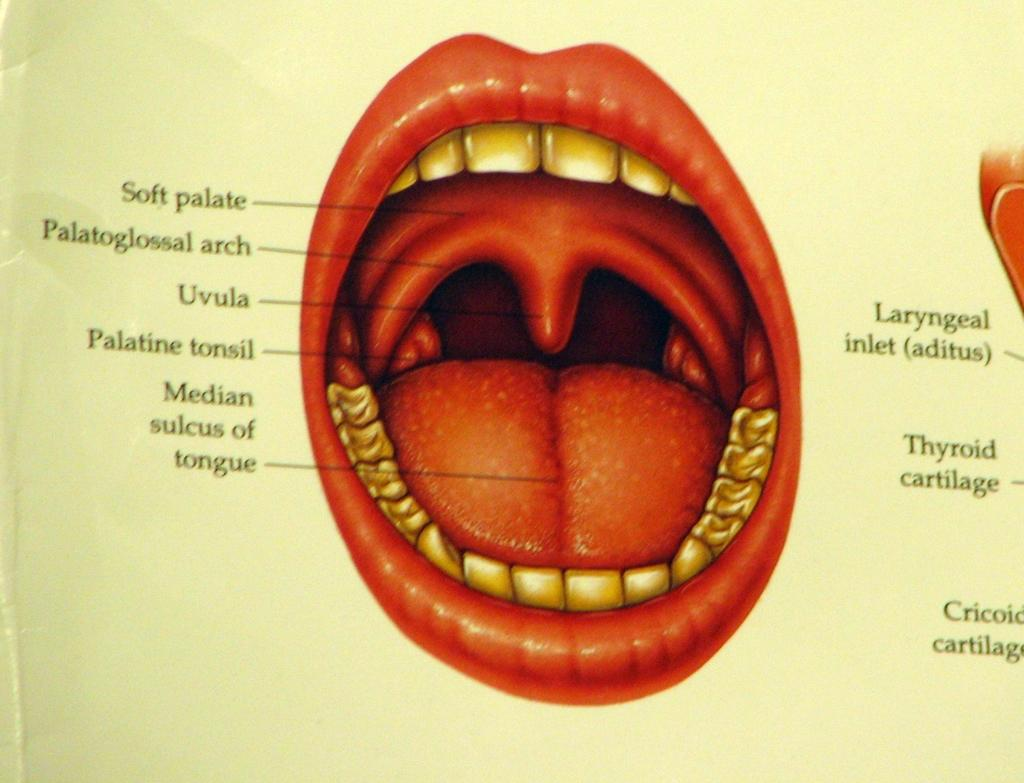What is depicted on the paper in the image? The paper contains a picture of a mouth. What specific features are included in the mouth picture? The picture includes a tongue, teeth, and lips. Is there any text present on the paper? Yes, there is text written on the paper. Can you tell me how many accounts are mentioned in the garden on the paper? There is no mention of accounts or gardens on the paper; it features a picture of a mouth with text. 